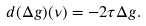<formula> <loc_0><loc_0><loc_500><loc_500>d ( \Delta g ) ( \nu ) = - 2 \tau \Delta g .</formula> 